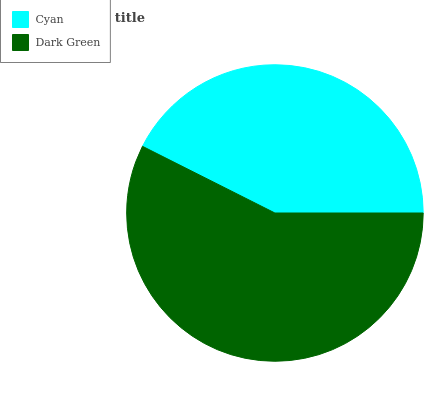Is Cyan the minimum?
Answer yes or no. Yes. Is Dark Green the maximum?
Answer yes or no. Yes. Is Dark Green the minimum?
Answer yes or no. No. Is Dark Green greater than Cyan?
Answer yes or no. Yes. Is Cyan less than Dark Green?
Answer yes or no. Yes. Is Cyan greater than Dark Green?
Answer yes or no. No. Is Dark Green less than Cyan?
Answer yes or no. No. Is Dark Green the high median?
Answer yes or no. Yes. Is Cyan the low median?
Answer yes or no. Yes. Is Cyan the high median?
Answer yes or no. No. Is Dark Green the low median?
Answer yes or no. No. 